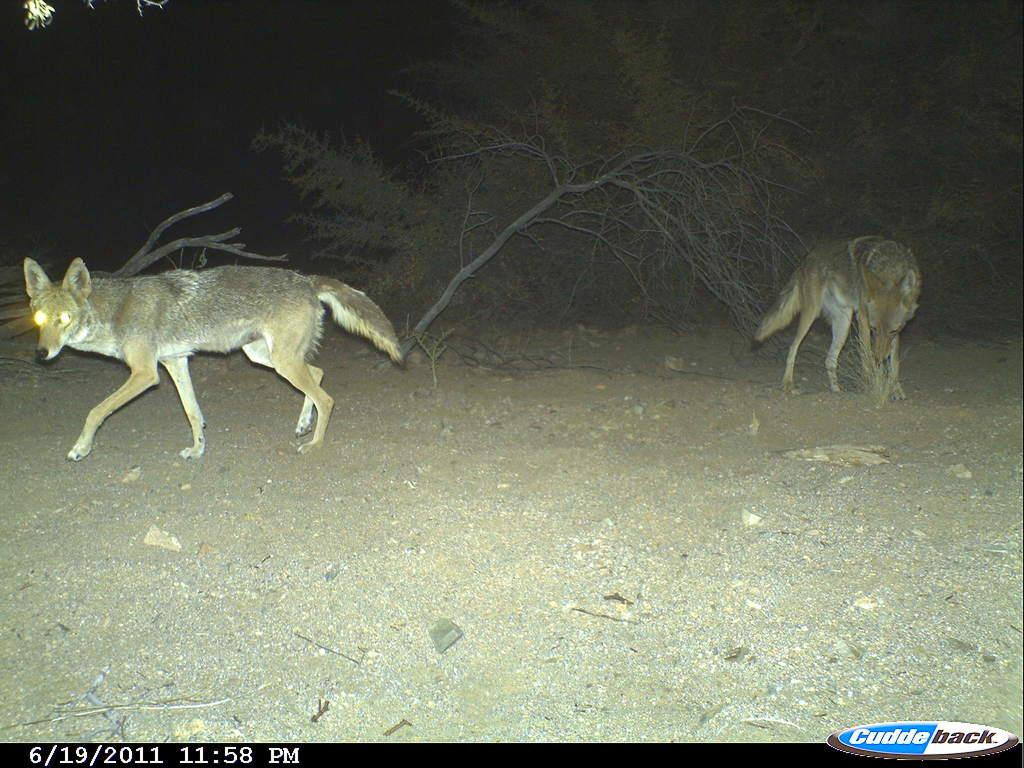What animals are present on the ground in the image? There are wolves on the ground in the image. What type of natural environment can be seen in the background of the image? There are trees in the background of the image. What type of bells can be heard ringing in the image? There are no bells present in the image, and therefore no sound can be heard. 